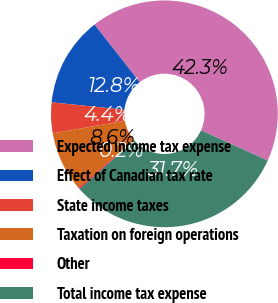Convert chart to OTSL. <chart><loc_0><loc_0><loc_500><loc_500><pie_chart><fcel>Expected income tax expense<fcel>Effect of Canadian tax rate<fcel>State income taxes<fcel>Taxation on foreign operations<fcel>Other<fcel>Total income tax expense<nl><fcel>42.32%<fcel>12.81%<fcel>4.38%<fcel>8.6%<fcel>0.17%<fcel>31.71%<nl></chart> 